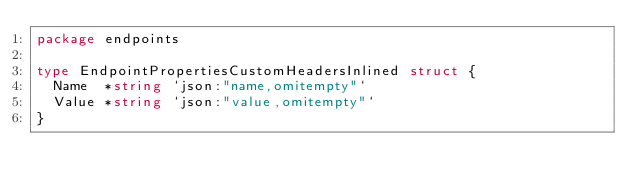Convert code to text. <code><loc_0><loc_0><loc_500><loc_500><_Go_>package endpoints

type EndpointPropertiesCustomHeadersInlined struct {
	Name  *string `json:"name,omitempty"`
	Value *string `json:"value,omitempty"`
}
</code> 